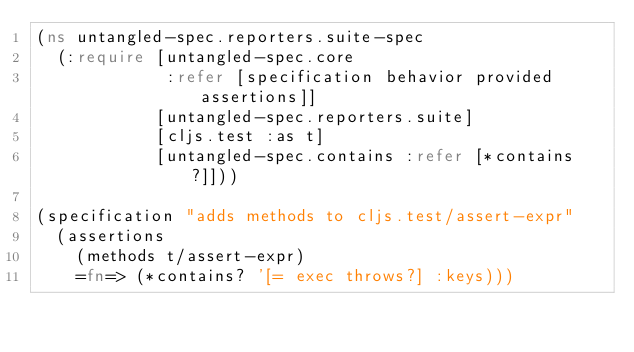<code> <loc_0><loc_0><loc_500><loc_500><_Clojure_>(ns untangled-spec.reporters.suite-spec
  (:require [untangled-spec.core
             :refer [specification behavior provided assertions]]
            [untangled-spec.reporters.suite]
            [cljs.test :as t]
            [untangled-spec.contains :refer [*contains?]]))

(specification "adds methods to cljs.test/assert-expr"
  (assertions
    (methods t/assert-expr)
    =fn=> (*contains? '[= exec throws?] :keys)))
</code> 